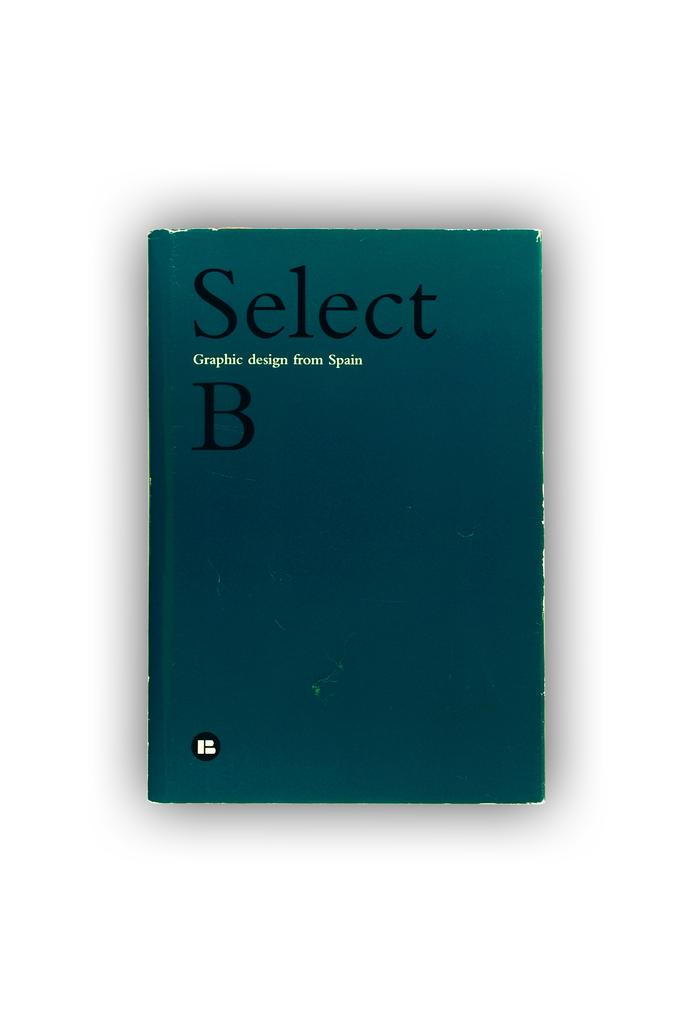<image>
Offer a succinct explanation of the picture presented. Select B Graphic design from Spain booklet that is blue 